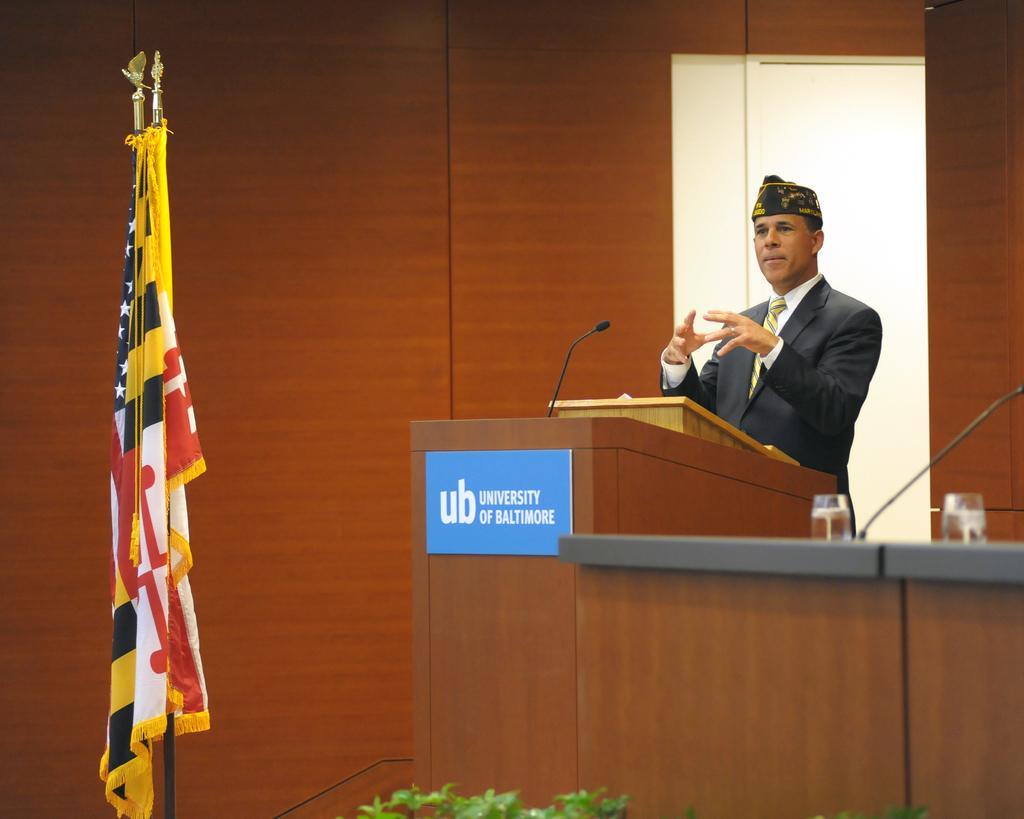Could you give a brief overview of what you see in this image? In front of the image there are plants, flags. There is a person standing in front of the podium. On top of it there is a mike. There is a board with some text on it. There are two glasses and a mike on the table. In the background of the image there is a wall. 